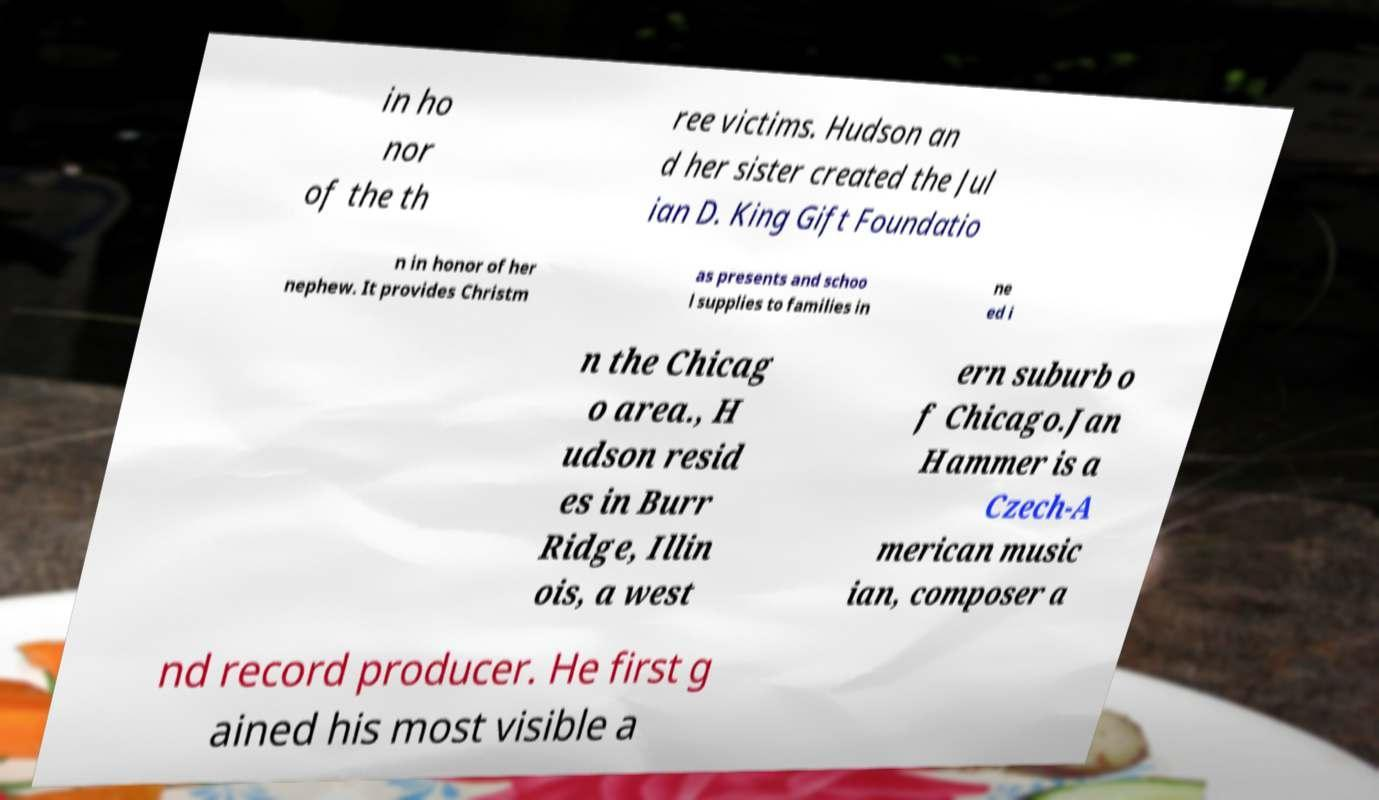Could you extract and type out the text from this image? in ho nor of the th ree victims. Hudson an d her sister created the Jul ian D. King Gift Foundatio n in honor of her nephew. It provides Christm as presents and schoo l supplies to families in ne ed i n the Chicag o area., H udson resid es in Burr Ridge, Illin ois, a west ern suburb o f Chicago.Jan Hammer is a Czech-A merican music ian, composer a nd record producer. He first g ained his most visible a 